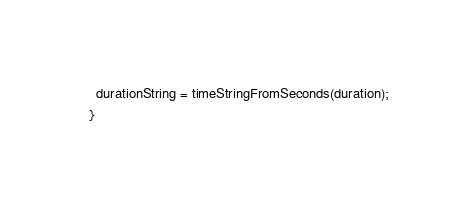<code> <loc_0><loc_0><loc_500><loc_500><_TypeScript_>    durationString = timeStringFromSeconds(duration);
  }
</code> 